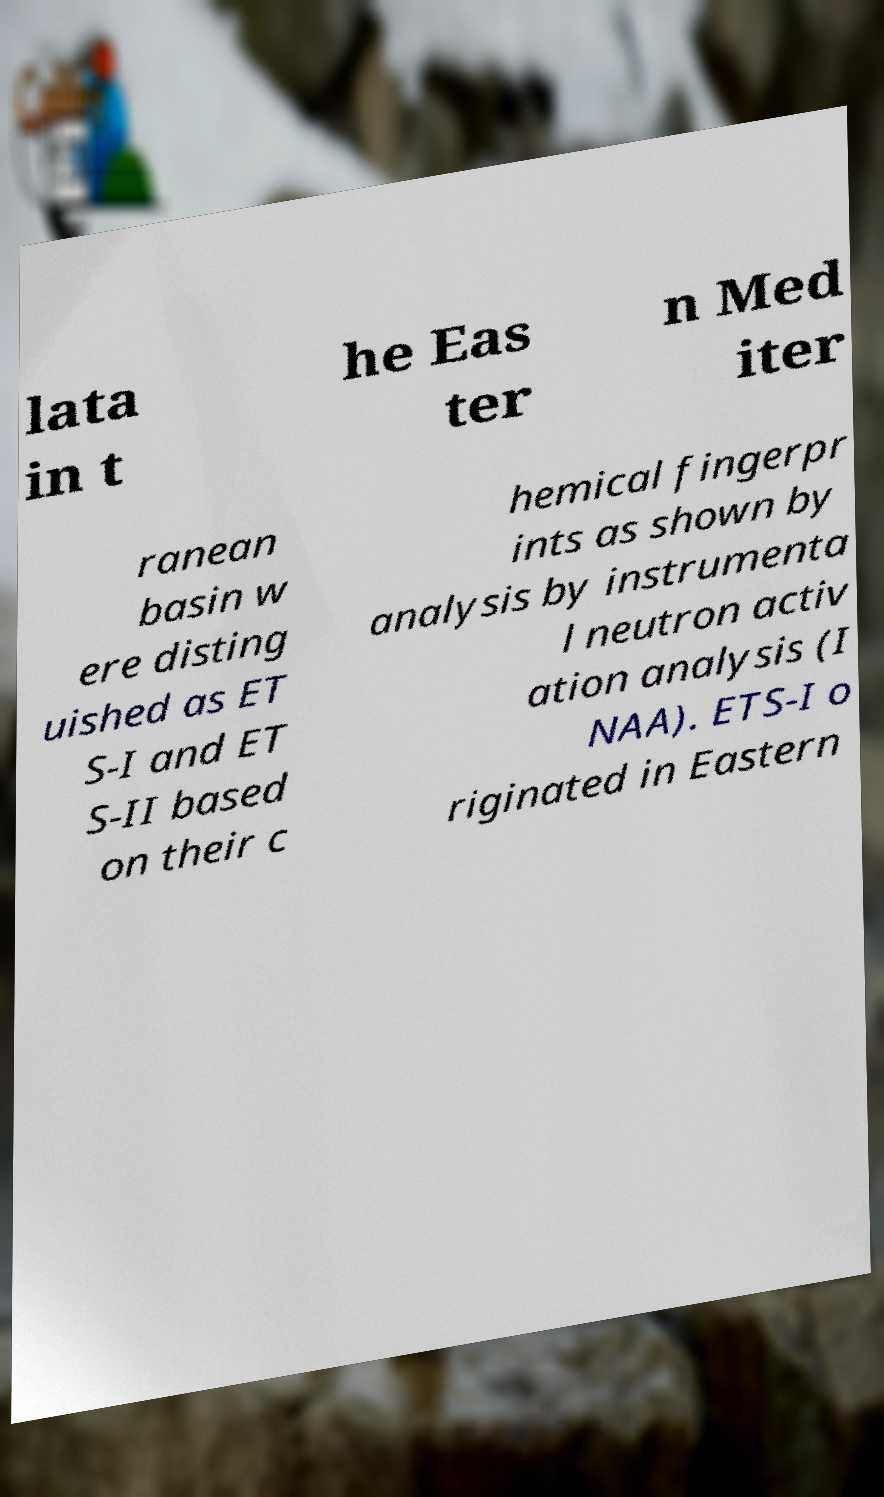What messages or text are displayed in this image? I need them in a readable, typed format. lata in t he Eas ter n Med iter ranean basin w ere disting uished as ET S-I and ET S-II based on their c hemical fingerpr ints as shown by analysis by instrumenta l neutron activ ation analysis (I NAA). ETS-I o riginated in Eastern 